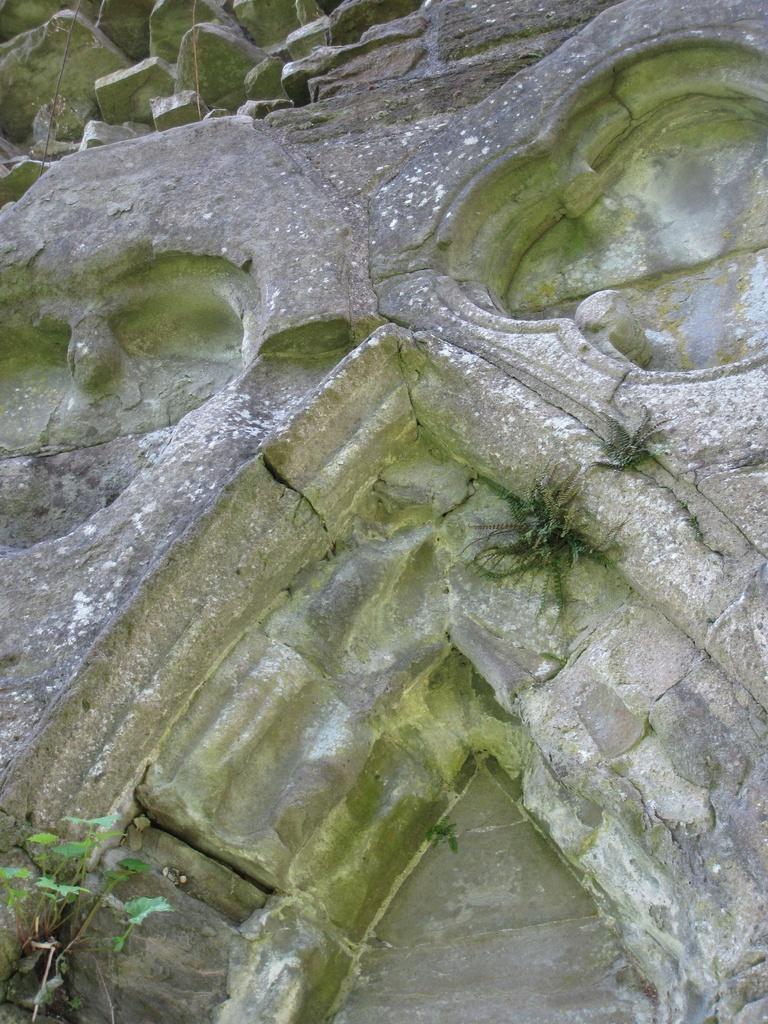Can you describe this image briefly? Here we can see a platform and on it we can see grass and small plants. At the top we can see stones. 